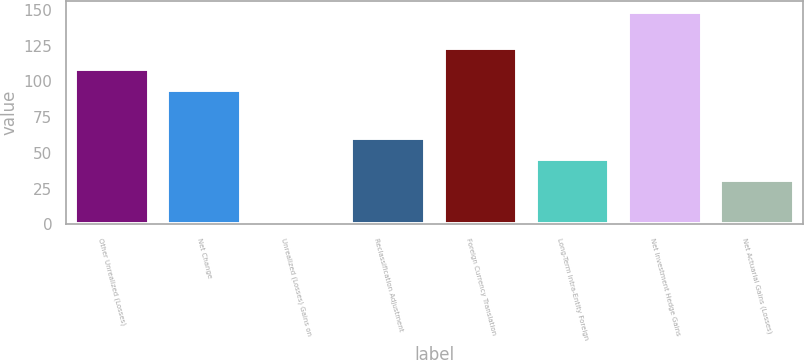<chart> <loc_0><loc_0><loc_500><loc_500><bar_chart><fcel>Other Unrealized (Losses)<fcel>Net Change<fcel>Unrealized (Losses) Gains on<fcel>Reclassification Adjustment<fcel>Foreign Currency Translation<fcel>Long-Term Intra-Entity Foreign<fcel>Net Investment Hedge Gains<fcel>Net Actuarial Gains (Losses)<nl><fcel>108.74<fcel>94<fcel>1.2<fcel>60.16<fcel>123.48<fcel>45.42<fcel>148.6<fcel>30.68<nl></chart> 